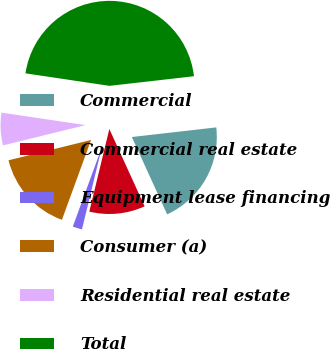Convert chart. <chart><loc_0><loc_0><loc_500><loc_500><pie_chart><fcel>Commercial<fcel>Commercial real estate<fcel>Equipment lease financing<fcel>Consumer (a)<fcel>Residential real estate<fcel>Total<nl><fcel>19.99%<fcel>10.6%<fcel>1.79%<fcel>15.59%<fcel>6.19%<fcel>45.84%<nl></chart> 